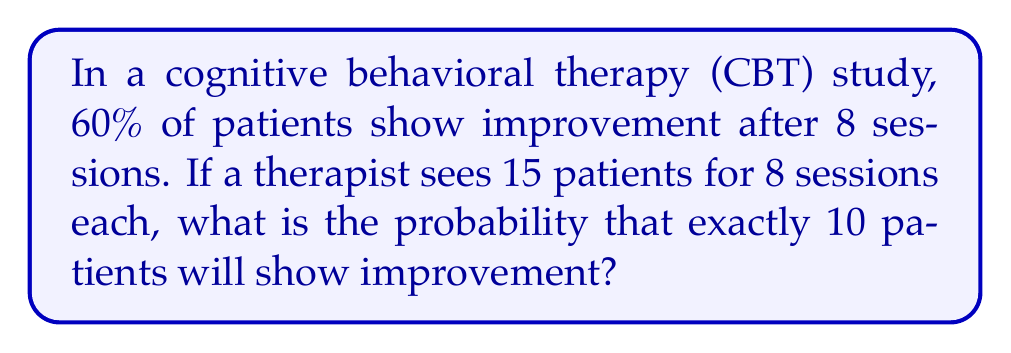Teach me how to tackle this problem. This problem can be solved using the binomial probability distribution.

1. Identify the parameters:
   $n = 15$ (number of patients)
   $p = 0.60$ (probability of improvement)
   $k = 10$ (number of successes we're interested in)

2. Use the binomial probability formula:
   $P(X = k) = \binom{n}{k} p^k (1-p)^{n-k}$

3. Calculate the binomial coefficient:
   $\binom{15}{10} = \frac{15!}{10!(15-10)!} = \frac{15!}{10!5!} = 3003$

4. Substitute the values into the formula:
   $P(X = 10) = 3003 \cdot (0.60)^{10} \cdot (1-0.60)^{15-10}$
   $= 3003 \cdot (0.60)^{10} \cdot (0.40)^5$

5. Calculate the result:
   $= 3003 \cdot 0.0060466176 \cdot 0.01024$
   $= 0.1847$

So, the probability of exactly 10 patients showing improvement out of 15 is approximately 0.1847 or 18.47%.
Answer: 0.1847 